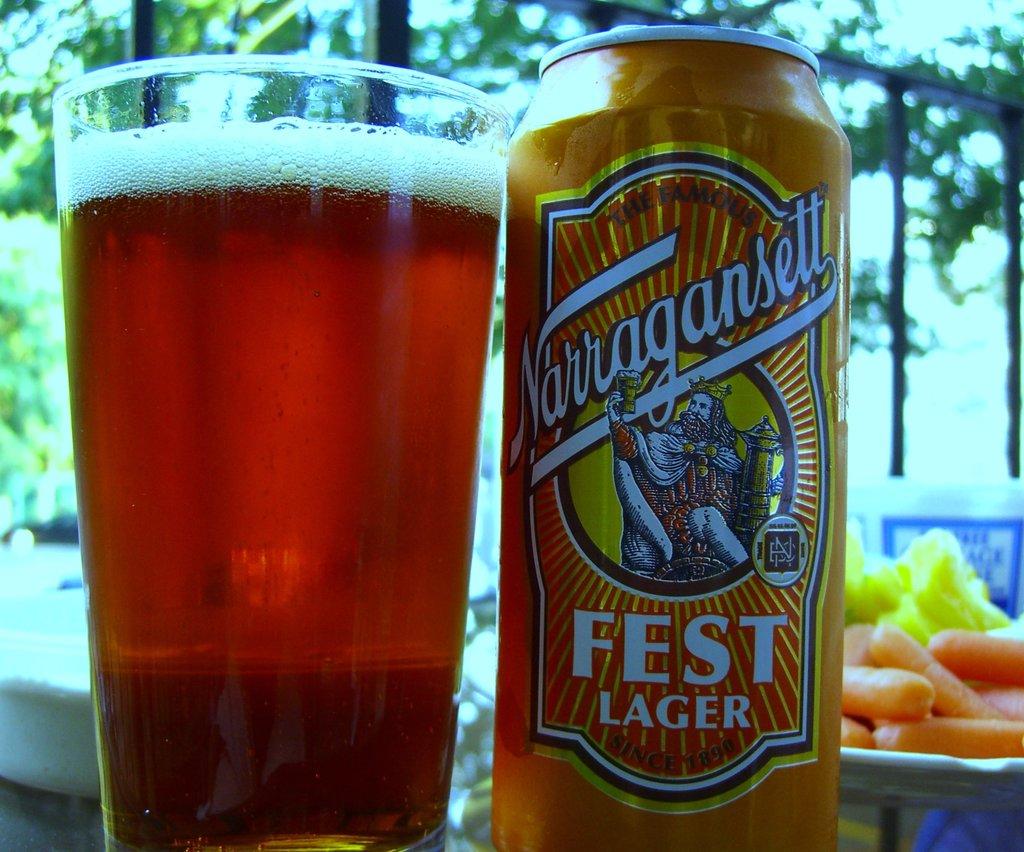What kind of lager is it?
Your response must be concise. Fest. 